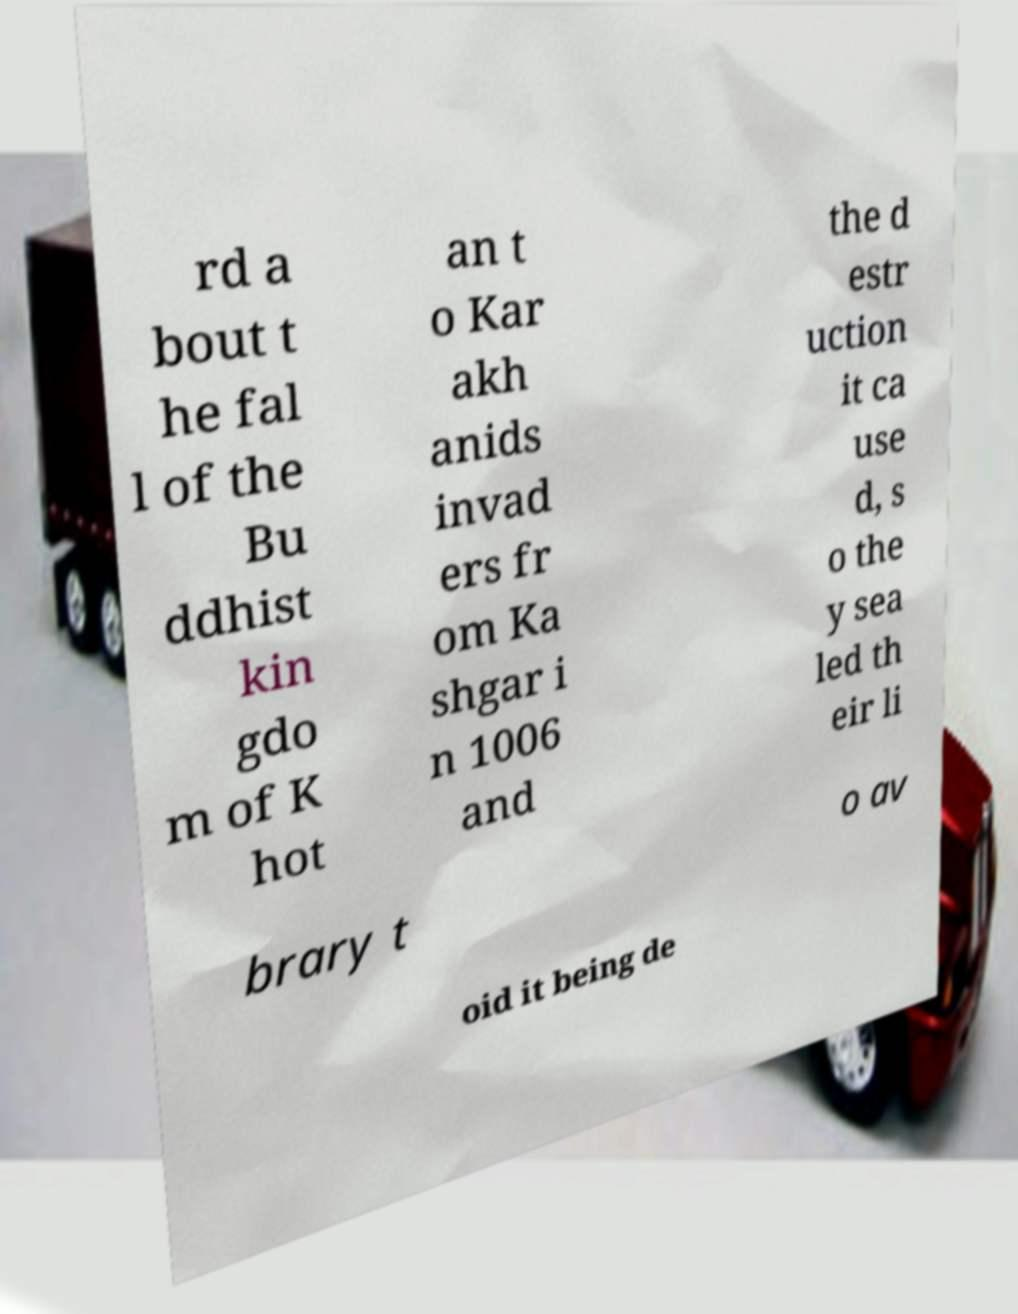What messages or text are displayed in this image? I need them in a readable, typed format. rd a bout t he fal l of the Bu ddhist kin gdo m of K hot an t o Kar akh anids invad ers fr om Ka shgar i n 1006 and the d estr uction it ca use d, s o the y sea led th eir li brary t o av oid it being de 